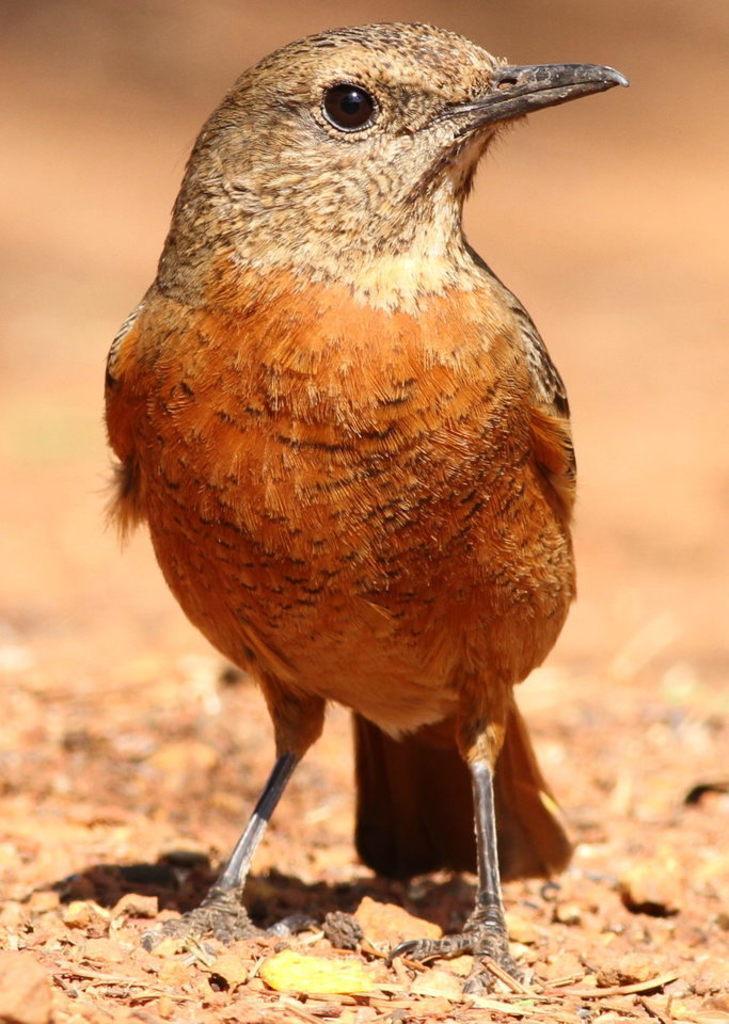Could you give a brief overview of what you see in this image? In the image there is a bird standing on the ground. Behind the bird there is a blur background. 